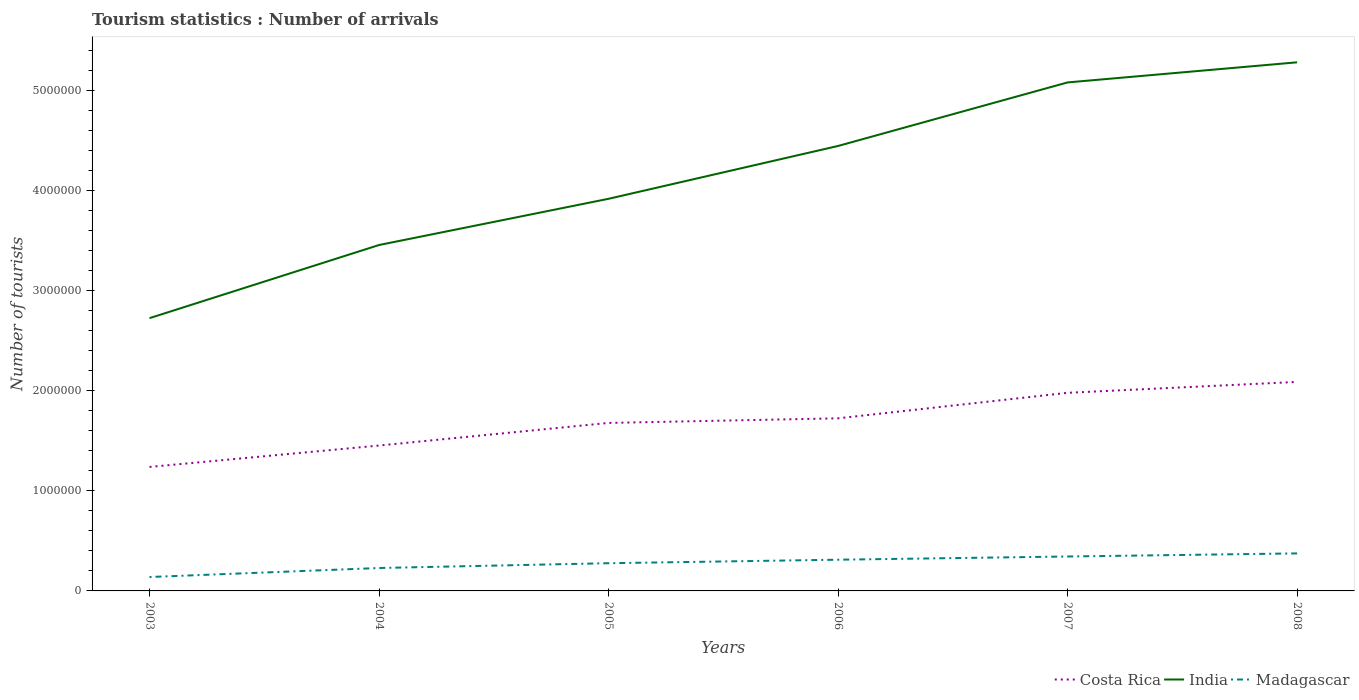How many different coloured lines are there?
Offer a very short reply. 3. Is the number of lines equal to the number of legend labels?
Keep it short and to the point. Yes. Across all years, what is the maximum number of tourist arrivals in Costa Rica?
Provide a short and direct response. 1.24e+06. What is the total number of tourist arrivals in Madagascar in the graph?
Offer a terse response. -6.30e+04. What is the difference between the highest and the second highest number of tourist arrivals in Madagascar?
Your answer should be compact. 2.36e+05. What is the difference between the highest and the lowest number of tourist arrivals in Costa Rica?
Provide a short and direct response. 3. How many lines are there?
Your answer should be compact. 3. Does the graph contain grids?
Ensure brevity in your answer.  No. How are the legend labels stacked?
Keep it short and to the point. Horizontal. What is the title of the graph?
Offer a very short reply. Tourism statistics : Number of arrivals. What is the label or title of the Y-axis?
Provide a succinct answer. Number of tourists. What is the Number of tourists in Costa Rica in 2003?
Offer a very short reply. 1.24e+06. What is the Number of tourists of India in 2003?
Offer a very short reply. 2.73e+06. What is the Number of tourists of Madagascar in 2003?
Offer a terse response. 1.39e+05. What is the Number of tourists in Costa Rica in 2004?
Keep it short and to the point. 1.45e+06. What is the Number of tourists of India in 2004?
Provide a short and direct response. 3.46e+06. What is the Number of tourists of Madagascar in 2004?
Your response must be concise. 2.29e+05. What is the Number of tourists in Costa Rica in 2005?
Make the answer very short. 1.68e+06. What is the Number of tourists in India in 2005?
Provide a succinct answer. 3.92e+06. What is the Number of tourists of Madagascar in 2005?
Ensure brevity in your answer.  2.77e+05. What is the Number of tourists in Costa Rica in 2006?
Make the answer very short. 1.72e+06. What is the Number of tourists in India in 2006?
Provide a short and direct response. 4.45e+06. What is the Number of tourists of Madagascar in 2006?
Your answer should be very brief. 3.12e+05. What is the Number of tourists of Costa Rica in 2007?
Your response must be concise. 1.98e+06. What is the Number of tourists of India in 2007?
Keep it short and to the point. 5.08e+06. What is the Number of tourists of Madagascar in 2007?
Ensure brevity in your answer.  3.44e+05. What is the Number of tourists in Costa Rica in 2008?
Provide a short and direct response. 2.09e+06. What is the Number of tourists in India in 2008?
Offer a terse response. 5.28e+06. What is the Number of tourists in Madagascar in 2008?
Your answer should be compact. 3.75e+05. Across all years, what is the maximum Number of tourists of Costa Rica?
Ensure brevity in your answer.  2.09e+06. Across all years, what is the maximum Number of tourists in India?
Provide a succinct answer. 5.28e+06. Across all years, what is the maximum Number of tourists of Madagascar?
Offer a terse response. 3.75e+05. Across all years, what is the minimum Number of tourists of Costa Rica?
Offer a terse response. 1.24e+06. Across all years, what is the minimum Number of tourists in India?
Ensure brevity in your answer.  2.73e+06. Across all years, what is the minimum Number of tourists in Madagascar?
Keep it short and to the point. 1.39e+05. What is the total Number of tourists of Costa Rica in the graph?
Give a very brief answer. 1.02e+07. What is the total Number of tourists in India in the graph?
Make the answer very short. 2.49e+07. What is the total Number of tourists of Madagascar in the graph?
Keep it short and to the point. 1.68e+06. What is the difference between the Number of tourists in Costa Rica in 2003 and that in 2004?
Provide a succinct answer. -2.14e+05. What is the difference between the Number of tourists in India in 2003 and that in 2004?
Keep it short and to the point. -7.31e+05. What is the difference between the Number of tourists of Costa Rica in 2003 and that in 2005?
Your answer should be very brief. -4.40e+05. What is the difference between the Number of tourists of India in 2003 and that in 2005?
Ensure brevity in your answer.  -1.19e+06. What is the difference between the Number of tourists in Madagascar in 2003 and that in 2005?
Provide a succinct answer. -1.38e+05. What is the difference between the Number of tourists in Costa Rica in 2003 and that in 2006?
Your answer should be compact. -4.86e+05. What is the difference between the Number of tourists of India in 2003 and that in 2006?
Your response must be concise. -1.72e+06. What is the difference between the Number of tourists of Madagascar in 2003 and that in 2006?
Keep it short and to the point. -1.73e+05. What is the difference between the Number of tourists in Costa Rica in 2003 and that in 2007?
Your answer should be compact. -7.41e+05. What is the difference between the Number of tourists in India in 2003 and that in 2007?
Ensure brevity in your answer.  -2.36e+06. What is the difference between the Number of tourists in Madagascar in 2003 and that in 2007?
Ensure brevity in your answer.  -2.05e+05. What is the difference between the Number of tourists in Costa Rica in 2003 and that in 2008?
Give a very brief answer. -8.50e+05. What is the difference between the Number of tourists in India in 2003 and that in 2008?
Provide a short and direct response. -2.56e+06. What is the difference between the Number of tourists in Madagascar in 2003 and that in 2008?
Provide a short and direct response. -2.36e+05. What is the difference between the Number of tourists in Costa Rica in 2004 and that in 2005?
Your answer should be compact. -2.26e+05. What is the difference between the Number of tourists in India in 2004 and that in 2005?
Your answer should be compact. -4.62e+05. What is the difference between the Number of tourists in Madagascar in 2004 and that in 2005?
Keep it short and to the point. -4.80e+04. What is the difference between the Number of tourists in Costa Rica in 2004 and that in 2006?
Your answer should be compact. -2.72e+05. What is the difference between the Number of tourists of India in 2004 and that in 2006?
Offer a terse response. -9.90e+05. What is the difference between the Number of tourists in Madagascar in 2004 and that in 2006?
Provide a short and direct response. -8.30e+04. What is the difference between the Number of tourists in Costa Rica in 2004 and that in 2007?
Offer a very short reply. -5.27e+05. What is the difference between the Number of tourists in India in 2004 and that in 2007?
Ensure brevity in your answer.  -1.62e+06. What is the difference between the Number of tourists in Madagascar in 2004 and that in 2007?
Ensure brevity in your answer.  -1.15e+05. What is the difference between the Number of tourists in Costa Rica in 2004 and that in 2008?
Offer a terse response. -6.36e+05. What is the difference between the Number of tourists in India in 2004 and that in 2008?
Keep it short and to the point. -1.83e+06. What is the difference between the Number of tourists of Madagascar in 2004 and that in 2008?
Keep it short and to the point. -1.46e+05. What is the difference between the Number of tourists in Costa Rica in 2005 and that in 2006?
Ensure brevity in your answer.  -4.60e+04. What is the difference between the Number of tourists of India in 2005 and that in 2006?
Make the answer very short. -5.28e+05. What is the difference between the Number of tourists of Madagascar in 2005 and that in 2006?
Offer a very short reply. -3.50e+04. What is the difference between the Number of tourists of Costa Rica in 2005 and that in 2007?
Offer a terse response. -3.01e+05. What is the difference between the Number of tourists in India in 2005 and that in 2007?
Ensure brevity in your answer.  -1.16e+06. What is the difference between the Number of tourists in Madagascar in 2005 and that in 2007?
Provide a short and direct response. -6.70e+04. What is the difference between the Number of tourists of Costa Rica in 2005 and that in 2008?
Offer a very short reply. -4.10e+05. What is the difference between the Number of tourists in India in 2005 and that in 2008?
Your answer should be compact. -1.36e+06. What is the difference between the Number of tourists in Madagascar in 2005 and that in 2008?
Keep it short and to the point. -9.80e+04. What is the difference between the Number of tourists of Costa Rica in 2006 and that in 2007?
Keep it short and to the point. -2.55e+05. What is the difference between the Number of tourists in India in 2006 and that in 2007?
Make the answer very short. -6.35e+05. What is the difference between the Number of tourists in Madagascar in 2006 and that in 2007?
Your answer should be compact. -3.20e+04. What is the difference between the Number of tourists of Costa Rica in 2006 and that in 2008?
Make the answer very short. -3.64e+05. What is the difference between the Number of tourists of India in 2006 and that in 2008?
Offer a very short reply. -8.36e+05. What is the difference between the Number of tourists of Madagascar in 2006 and that in 2008?
Make the answer very short. -6.30e+04. What is the difference between the Number of tourists of Costa Rica in 2007 and that in 2008?
Offer a very short reply. -1.09e+05. What is the difference between the Number of tourists in India in 2007 and that in 2008?
Offer a very short reply. -2.01e+05. What is the difference between the Number of tourists of Madagascar in 2007 and that in 2008?
Your response must be concise. -3.10e+04. What is the difference between the Number of tourists in Costa Rica in 2003 and the Number of tourists in India in 2004?
Provide a short and direct response. -2.22e+06. What is the difference between the Number of tourists in Costa Rica in 2003 and the Number of tourists in Madagascar in 2004?
Provide a short and direct response. 1.01e+06. What is the difference between the Number of tourists in India in 2003 and the Number of tourists in Madagascar in 2004?
Offer a terse response. 2.50e+06. What is the difference between the Number of tourists of Costa Rica in 2003 and the Number of tourists of India in 2005?
Your answer should be very brief. -2.68e+06. What is the difference between the Number of tourists in Costa Rica in 2003 and the Number of tourists in Madagascar in 2005?
Keep it short and to the point. 9.62e+05. What is the difference between the Number of tourists of India in 2003 and the Number of tourists of Madagascar in 2005?
Your answer should be very brief. 2.45e+06. What is the difference between the Number of tourists of Costa Rica in 2003 and the Number of tourists of India in 2006?
Your answer should be very brief. -3.21e+06. What is the difference between the Number of tourists in Costa Rica in 2003 and the Number of tourists in Madagascar in 2006?
Make the answer very short. 9.27e+05. What is the difference between the Number of tourists in India in 2003 and the Number of tourists in Madagascar in 2006?
Provide a short and direct response. 2.41e+06. What is the difference between the Number of tourists of Costa Rica in 2003 and the Number of tourists of India in 2007?
Provide a short and direct response. -3.84e+06. What is the difference between the Number of tourists of Costa Rica in 2003 and the Number of tourists of Madagascar in 2007?
Provide a short and direct response. 8.95e+05. What is the difference between the Number of tourists of India in 2003 and the Number of tourists of Madagascar in 2007?
Provide a succinct answer. 2.38e+06. What is the difference between the Number of tourists of Costa Rica in 2003 and the Number of tourists of India in 2008?
Offer a very short reply. -4.04e+06. What is the difference between the Number of tourists in Costa Rica in 2003 and the Number of tourists in Madagascar in 2008?
Give a very brief answer. 8.64e+05. What is the difference between the Number of tourists of India in 2003 and the Number of tourists of Madagascar in 2008?
Offer a very short reply. 2.35e+06. What is the difference between the Number of tourists in Costa Rica in 2004 and the Number of tourists in India in 2005?
Make the answer very short. -2.47e+06. What is the difference between the Number of tourists of Costa Rica in 2004 and the Number of tourists of Madagascar in 2005?
Offer a terse response. 1.18e+06. What is the difference between the Number of tourists of India in 2004 and the Number of tourists of Madagascar in 2005?
Your answer should be very brief. 3.18e+06. What is the difference between the Number of tourists of Costa Rica in 2004 and the Number of tourists of India in 2006?
Your answer should be very brief. -2.99e+06. What is the difference between the Number of tourists of Costa Rica in 2004 and the Number of tourists of Madagascar in 2006?
Ensure brevity in your answer.  1.14e+06. What is the difference between the Number of tourists of India in 2004 and the Number of tourists of Madagascar in 2006?
Make the answer very short. 3.14e+06. What is the difference between the Number of tourists of Costa Rica in 2004 and the Number of tourists of India in 2007?
Make the answer very short. -3.63e+06. What is the difference between the Number of tourists in Costa Rica in 2004 and the Number of tourists in Madagascar in 2007?
Make the answer very short. 1.11e+06. What is the difference between the Number of tourists of India in 2004 and the Number of tourists of Madagascar in 2007?
Your response must be concise. 3.11e+06. What is the difference between the Number of tourists in Costa Rica in 2004 and the Number of tourists in India in 2008?
Offer a very short reply. -3.83e+06. What is the difference between the Number of tourists in Costa Rica in 2004 and the Number of tourists in Madagascar in 2008?
Make the answer very short. 1.08e+06. What is the difference between the Number of tourists in India in 2004 and the Number of tourists in Madagascar in 2008?
Give a very brief answer. 3.08e+06. What is the difference between the Number of tourists in Costa Rica in 2005 and the Number of tourists in India in 2006?
Your answer should be very brief. -2.77e+06. What is the difference between the Number of tourists in Costa Rica in 2005 and the Number of tourists in Madagascar in 2006?
Ensure brevity in your answer.  1.37e+06. What is the difference between the Number of tourists of India in 2005 and the Number of tourists of Madagascar in 2006?
Keep it short and to the point. 3.61e+06. What is the difference between the Number of tourists of Costa Rica in 2005 and the Number of tourists of India in 2007?
Your answer should be compact. -3.40e+06. What is the difference between the Number of tourists of Costa Rica in 2005 and the Number of tourists of Madagascar in 2007?
Your answer should be compact. 1.34e+06. What is the difference between the Number of tourists in India in 2005 and the Number of tourists in Madagascar in 2007?
Provide a succinct answer. 3.58e+06. What is the difference between the Number of tourists of Costa Rica in 2005 and the Number of tourists of India in 2008?
Your answer should be very brief. -3.60e+06. What is the difference between the Number of tourists of Costa Rica in 2005 and the Number of tourists of Madagascar in 2008?
Make the answer very short. 1.30e+06. What is the difference between the Number of tourists of India in 2005 and the Number of tourists of Madagascar in 2008?
Offer a very short reply. 3.54e+06. What is the difference between the Number of tourists of Costa Rica in 2006 and the Number of tourists of India in 2007?
Ensure brevity in your answer.  -3.36e+06. What is the difference between the Number of tourists of Costa Rica in 2006 and the Number of tourists of Madagascar in 2007?
Provide a succinct answer. 1.38e+06. What is the difference between the Number of tourists of India in 2006 and the Number of tourists of Madagascar in 2007?
Ensure brevity in your answer.  4.10e+06. What is the difference between the Number of tourists of Costa Rica in 2006 and the Number of tourists of India in 2008?
Offer a very short reply. -3.56e+06. What is the difference between the Number of tourists in Costa Rica in 2006 and the Number of tourists in Madagascar in 2008?
Your answer should be very brief. 1.35e+06. What is the difference between the Number of tourists of India in 2006 and the Number of tourists of Madagascar in 2008?
Give a very brief answer. 4.07e+06. What is the difference between the Number of tourists in Costa Rica in 2007 and the Number of tourists in India in 2008?
Provide a short and direct response. -3.30e+06. What is the difference between the Number of tourists of Costa Rica in 2007 and the Number of tourists of Madagascar in 2008?
Provide a short and direct response. 1.60e+06. What is the difference between the Number of tourists in India in 2007 and the Number of tourists in Madagascar in 2008?
Ensure brevity in your answer.  4.71e+06. What is the average Number of tourists in Costa Rica per year?
Offer a very short reply. 1.69e+06. What is the average Number of tourists in India per year?
Provide a succinct answer. 4.15e+06. What is the average Number of tourists of Madagascar per year?
Offer a terse response. 2.79e+05. In the year 2003, what is the difference between the Number of tourists in Costa Rica and Number of tourists in India?
Make the answer very short. -1.49e+06. In the year 2003, what is the difference between the Number of tourists in Costa Rica and Number of tourists in Madagascar?
Make the answer very short. 1.10e+06. In the year 2003, what is the difference between the Number of tourists of India and Number of tourists of Madagascar?
Provide a succinct answer. 2.59e+06. In the year 2004, what is the difference between the Number of tourists in Costa Rica and Number of tourists in India?
Give a very brief answer. -2.00e+06. In the year 2004, what is the difference between the Number of tourists in Costa Rica and Number of tourists in Madagascar?
Your response must be concise. 1.22e+06. In the year 2004, what is the difference between the Number of tourists of India and Number of tourists of Madagascar?
Provide a short and direct response. 3.23e+06. In the year 2005, what is the difference between the Number of tourists of Costa Rica and Number of tourists of India?
Your answer should be compact. -2.24e+06. In the year 2005, what is the difference between the Number of tourists of Costa Rica and Number of tourists of Madagascar?
Offer a very short reply. 1.40e+06. In the year 2005, what is the difference between the Number of tourists of India and Number of tourists of Madagascar?
Provide a short and direct response. 3.64e+06. In the year 2006, what is the difference between the Number of tourists of Costa Rica and Number of tourists of India?
Keep it short and to the point. -2.72e+06. In the year 2006, what is the difference between the Number of tourists of Costa Rica and Number of tourists of Madagascar?
Ensure brevity in your answer.  1.41e+06. In the year 2006, what is the difference between the Number of tourists of India and Number of tourists of Madagascar?
Provide a succinct answer. 4.14e+06. In the year 2007, what is the difference between the Number of tourists of Costa Rica and Number of tourists of India?
Offer a very short reply. -3.10e+06. In the year 2007, what is the difference between the Number of tourists of Costa Rica and Number of tourists of Madagascar?
Ensure brevity in your answer.  1.64e+06. In the year 2007, what is the difference between the Number of tourists of India and Number of tourists of Madagascar?
Keep it short and to the point. 4.74e+06. In the year 2008, what is the difference between the Number of tourists in Costa Rica and Number of tourists in India?
Give a very brief answer. -3.19e+06. In the year 2008, what is the difference between the Number of tourists of Costa Rica and Number of tourists of Madagascar?
Give a very brief answer. 1.71e+06. In the year 2008, what is the difference between the Number of tourists of India and Number of tourists of Madagascar?
Offer a terse response. 4.91e+06. What is the ratio of the Number of tourists in Costa Rica in 2003 to that in 2004?
Give a very brief answer. 0.85. What is the ratio of the Number of tourists of India in 2003 to that in 2004?
Your response must be concise. 0.79. What is the ratio of the Number of tourists of Madagascar in 2003 to that in 2004?
Keep it short and to the point. 0.61. What is the ratio of the Number of tourists in Costa Rica in 2003 to that in 2005?
Offer a very short reply. 0.74. What is the ratio of the Number of tourists of India in 2003 to that in 2005?
Make the answer very short. 0.7. What is the ratio of the Number of tourists of Madagascar in 2003 to that in 2005?
Provide a succinct answer. 0.5. What is the ratio of the Number of tourists in Costa Rica in 2003 to that in 2006?
Ensure brevity in your answer.  0.72. What is the ratio of the Number of tourists in India in 2003 to that in 2006?
Your answer should be very brief. 0.61. What is the ratio of the Number of tourists of Madagascar in 2003 to that in 2006?
Your response must be concise. 0.45. What is the ratio of the Number of tourists in Costa Rica in 2003 to that in 2007?
Offer a terse response. 0.63. What is the ratio of the Number of tourists in India in 2003 to that in 2007?
Give a very brief answer. 0.54. What is the ratio of the Number of tourists of Madagascar in 2003 to that in 2007?
Ensure brevity in your answer.  0.4. What is the ratio of the Number of tourists in Costa Rica in 2003 to that in 2008?
Your answer should be very brief. 0.59. What is the ratio of the Number of tourists of India in 2003 to that in 2008?
Offer a terse response. 0.52. What is the ratio of the Number of tourists of Madagascar in 2003 to that in 2008?
Your answer should be very brief. 0.37. What is the ratio of the Number of tourists of Costa Rica in 2004 to that in 2005?
Your answer should be compact. 0.87. What is the ratio of the Number of tourists of India in 2004 to that in 2005?
Provide a succinct answer. 0.88. What is the ratio of the Number of tourists in Madagascar in 2004 to that in 2005?
Keep it short and to the point. 0.83. What is the ratio of the Number of tourists in Costa Rica in 2004 to that in 2006?
Provide a short and direct response. 0.84. What is the ratio of the Number of tourists in India in 2004 to that in 2006?
Provide a succinct answer. 0.78. What is the ratio of the Number of tourists in Madagascar in 2004 to that in 2006?
Make the answer very short. 0.73. What is the ratio of the Number of tourists of Costa Rica in 2004 to that in 2007?
Offer a very short reply. 0.73. What is the ratio of the Number of tourists in India in 2004 to that in 2007?
Give a very brief answer. 0.68. What is the ratio of the Number of tourists in Madagascar in 2004 to that in 2007?
Ensure brevity in your answer.  0.67. What is the ratio of the Number of tourists in Costa Rica in 2004 to that in 2008?
Your answer should be very brief. 0.7. What is the ratio of the Number of tourists in India in 2004 to that in 2008?
Your answer should be very brief. 0.65. What is the ratio of the Number of tourists of Madagascar in 2004 to that in 2008?
Keep it short and to the point. 0.61. What is the ratio of the Number of tourists of Costa Rica in 2005 to that in 2006?
Make the answer very short. 0.97. What is the ratio of the Number of tourists of India in 2005 to that in 2006?
Give a very brief answer. 0.88. What is the ratio of the Number of tourists in Madagascar in 2005 to that in 2006?
Give a very brief answer. 0.89. What is the ratio of the Number of tourists in Costa Rica in 2005 to that in 2007?
Give a very brief answer. 0.85. What is the ratio of the Number of tourists of India in 2005 to that in 2007?
Offer a terse response. 0.77. What is the ratio of the Number of tourists of Madagascar in 2005 to that in 2007?
Offer a very short reply. 0.81. What is the ratio of the Number of tourists in Costa Rica in 2005 to that in 2008?
Offer a very short reply. 0.8. What is the ratio of the Number of tourists in India in 2005 to that in 2008?
Give a very brief answer. 0.74. What is the ratio of the Number of tourists in Madagascar in 2005 to that in 2008?
Your answer should be very brief. 0.74. What is the ratio of the Number of tourists of Costa Rica in 2006 to that in 2007?
Your response must be concise. 0.87. What is the ratio of the Number of tourists of India in 2006 to that in 2007?
Your answer should be very brief. 0.88. What is the ratio of the Number of tourists of Madagascar in 2006 to that in 2007?
Make the answer very short. 0.91. What is the ratio of the Number of tourists in Costa Rica in 2006 to that in 2008?
Make the answer very short. 0.83. What is the ratio of the Number of tourists of India in 2006 to that in 2008?
Your response must be concise. 0.84. What is the ratio of the Number of tourists of Madagascar in 2006 to that in 2008?
Provide a succinct answer. 0.83. What is the ratio of the Number of tourists in Costa Rica in 2007 to that in 2008?
Your answer should be very brief. 0.95. What is the ratio of the Number of tourists of Madagascar in 2007 to that in 2008?
Your answer should be compact. 0.92. What is the difference between the highest and the second highest Number of tourists of Costa Rica?
Make the answer very short. 1.09e+05. What is the difference between the highest and the second highest Number of tourists of India?
Keep it short and to the point. 2.01e+05. What is the difference between the highest and the second highest Number of tourists in Madagascar?
Give a very brief answer. 3.10e+04. What is the difference between the highest and the lowest Number of tourists of Costa Rica?
Provide a succinct answer. 8.50e+05. What is the difference between the highest and the lowest Number of tourists in India?
Provide a short and direct response. 2.56e+06. What is the difference between the highest and the lowest Number of tourists in Madagascar?
Offer a terse response. 2.36e+05. 